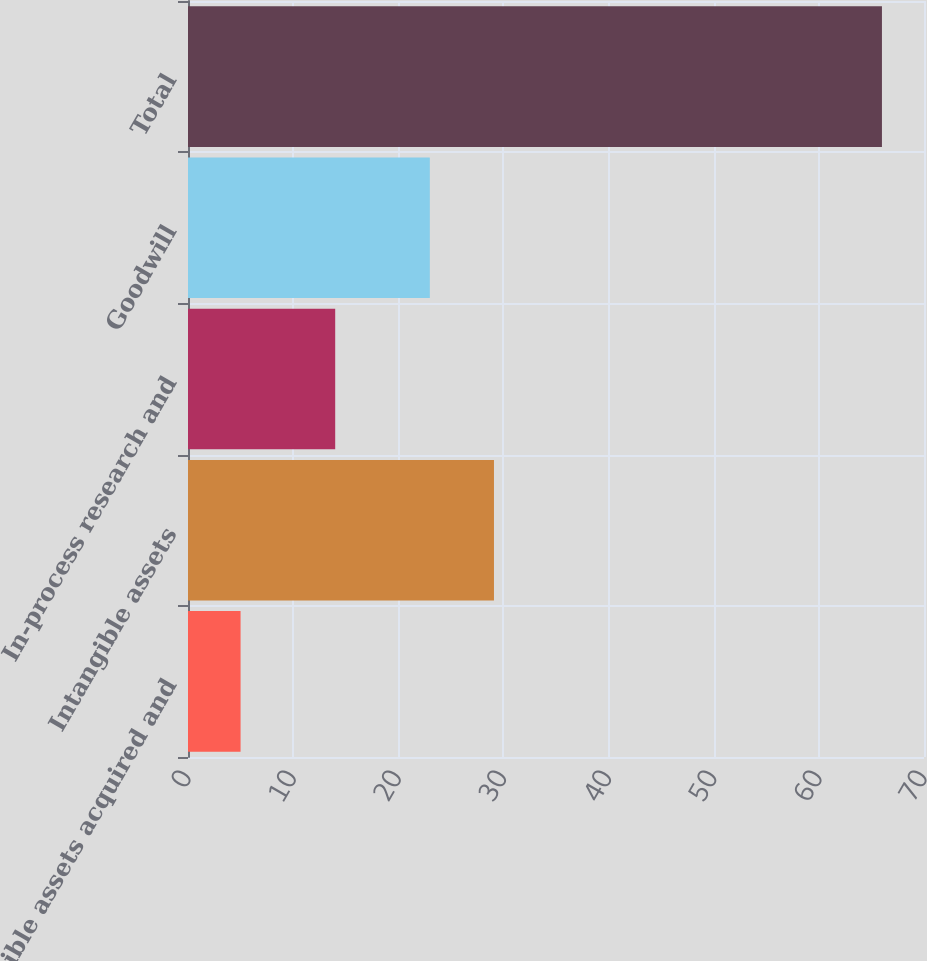<chart> <loc_0><loc_0><loc_500><loc_500><bar_chart><fcel>Tangible assets acquired and<fcel>Intangible assets<fcel>In-process research and<fcel>Goodwill<fcel>Total<nl><fcel>5<fcel>29.1<fcel>14<fcel>23<fcel>66<nl></chart> 